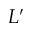Convert formula to latex. <formula><loc_0><loc_0><loc_500><loc_500>L ^ { \prime }</formula> 